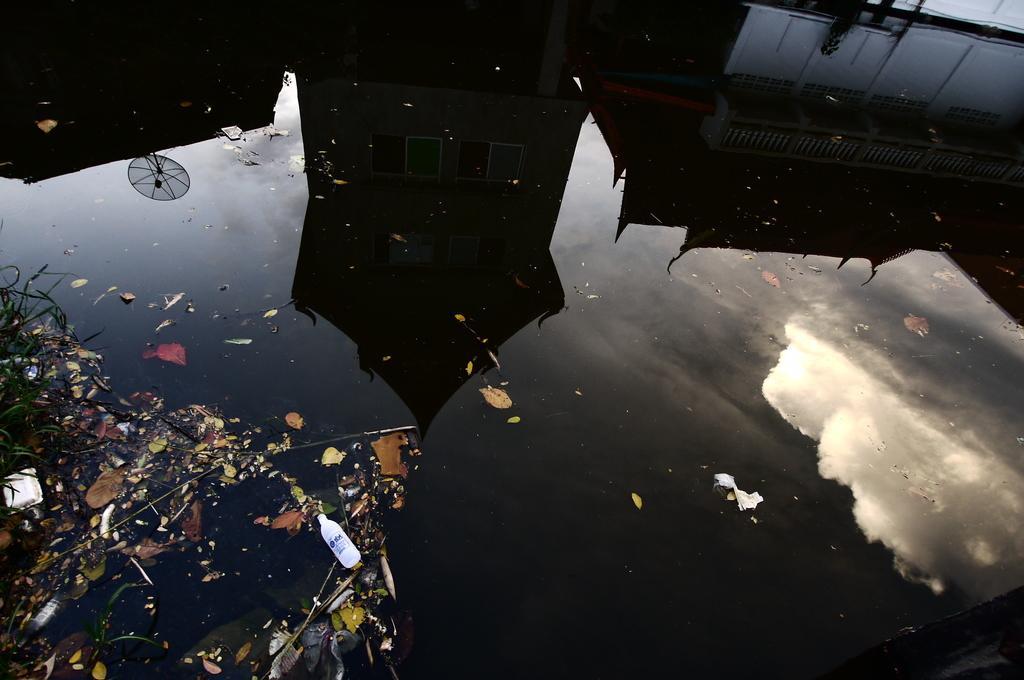In one or two sentences, can you explain what this image depicts? In this image, we can see building reflection on the water. 